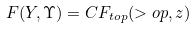Convert formula to latex. <formula><loc_0><loc_0><loc_500><loc_500>F ( Y , \Upsilon ) = C F _ { t o p } ( > o p , z )</formula> 